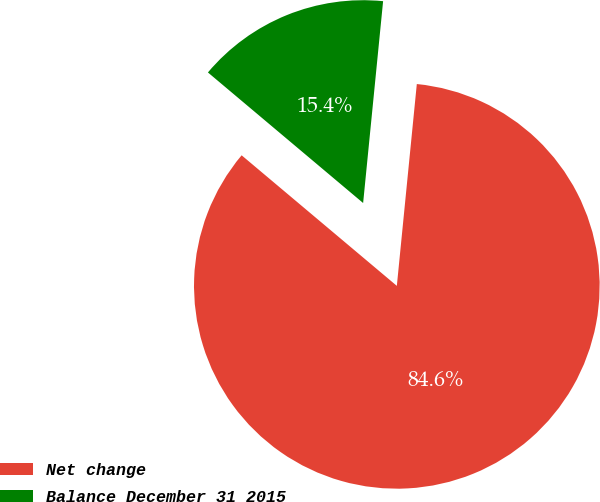Convert chart to OTSL. <chart><loc_0><loc_0><loc_500><loc_500><pie_chart><fcel>Net change<fcel>Balance December 31 2015<nl><fcel>84.56%<fcel>15.44%<nl></chart> 